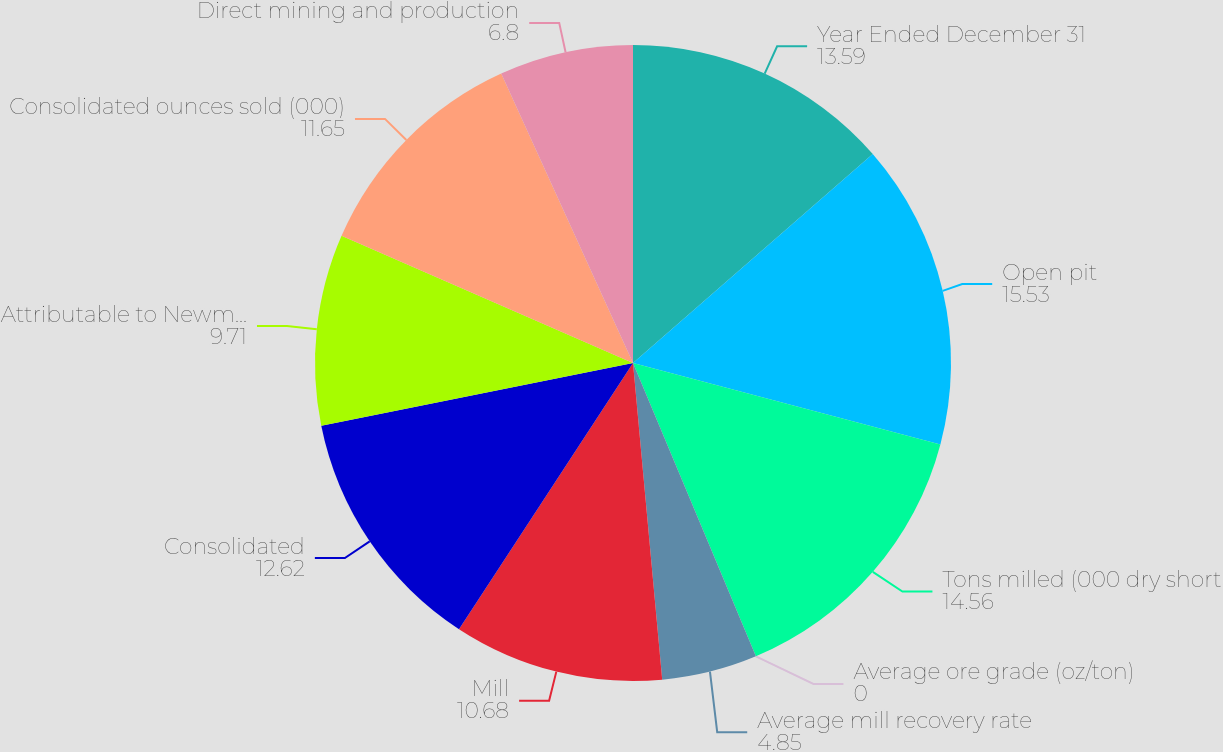Convert chart to OTSL. <chart><loc_0><loc_0><loc_500><loc_500><pie_chart><fcel>Year Ended December 31<fcel>Open pit<fcel>Tons milled (000 dry short<fcel>Average ore grade (oz/ton)<fcel>Average mill recovery rate<fcel>Mill<fcel>Consolidated<fcel>Attributable to Newmont<fcel>Consolidated ounces sold (000)<fcel>Direct mining and production<nl><fcel>13.59%<fcel>15.53%<fcel>14.56%<fcel>0.0%<fcel>4.85%<fcel>10.68%<fcel>12.62%<fcel>9.71%<fcel>11.65%<fcel>6.8%<nl></chart> 